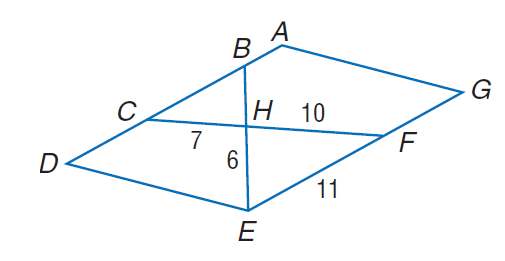Answer the mathemtical geometry problem and directly provide the correct option letter.
Question: Find the perimeter of \triangle C B H, if \triangle C B H \sim \triangle F E H, A D E G is a parallelogram, C H = 7, F H = 10, F E = 11, and E H = 6.
Choices: A: 18.9 B: 23.1 C: 31.5 D: 38.6 A 